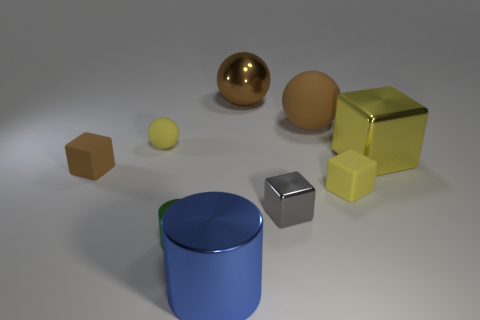Add 1 blue shiny cylinders. How many objects exist? 10 Subtract all cubes. How many objects are left? 5 Add 3 purple matte blocks. How many purple matte blocks exist? 3 Subtract 0 red balls. How many objects are left? 9 Subtract all big brown spheres. Subtract all metallic blocks. How many objects are left? 5 Add 3 small yellow cubes. How many small yellow cubes are left? 4 